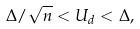Convert formula to latex. <formula><loc_0><loc_0><loc_500><loc_500>\Delta / \sqrt { n } < U _ { d } < \Delta ,</formula> 